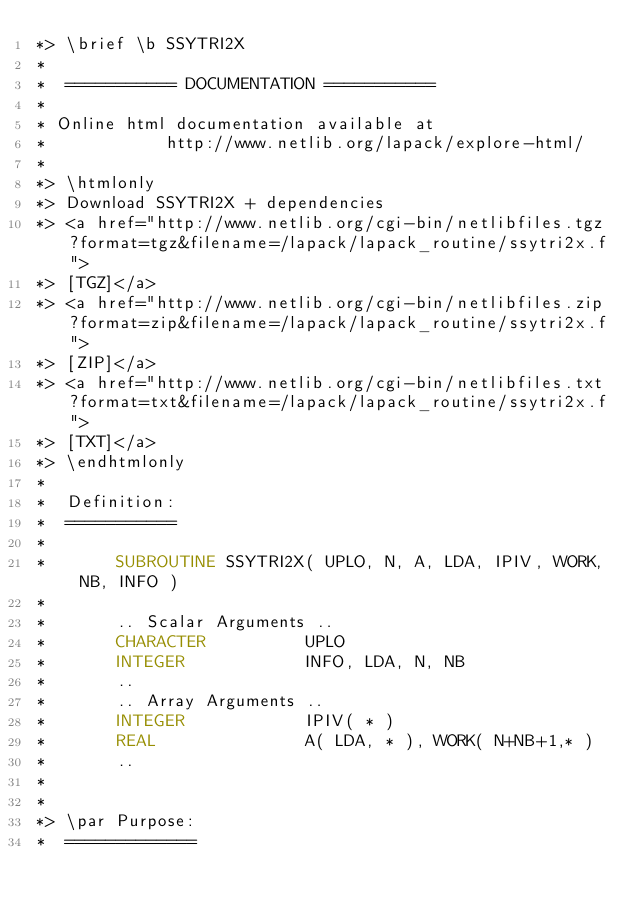Convert code to text. <code><loc_0><loc_0><loc_500><loc_500><_FORTRAN_>*> \brief \b SSYTRI2X
*
*  =========== DOCUMENTATION ===========
*
* Online html documentation available at 
*            http://www.netlib.org/lapack/explore-html/ 
*
*> \htmlonly
*> Download SSYTRI2X + dependencies 
*> <a href="http://www.netlib.org/cgi-bin/netlibfiles.tgz?format=tgz&filename=/lapack/lapack_routine/ssytri2x.f"> 
*> [TGZ]</a> 
*> <a href="http://www.netlib.org/cgi-bin/netlibfiles.zip?format=zip&filename=/lapack/lapack_routine/ssytri2x.f"> 
*> [ZIP]</a> 
*> <a href="http://www.netlib.org/cgi-bin/netlibfiles.txt?format=txt&filename=/lapack/lapack_routine/ssytri2x.f"> 
*> [TXT]</a>
*> \endhtmlonly 
*
*  Definition:
*  ===========
*
*       SUBROUTINE SSYTRI2X( UPLO, N, A, LDA, IPIV, WORK, NB, INFO )
* 
*       .. Scalar Arguments ..
*       CHARACTER          UPLO
*       INTEGER            INFO, LDA, N, NB
*       ..
*       .. Array Arguments ..
*       INTEGER            IPIV( * )
*       REAL               A( LDA, * ), WORK( N+NB+1,* )
*       ..
*  
*
*> \par Purpose:
*  =============</code> 